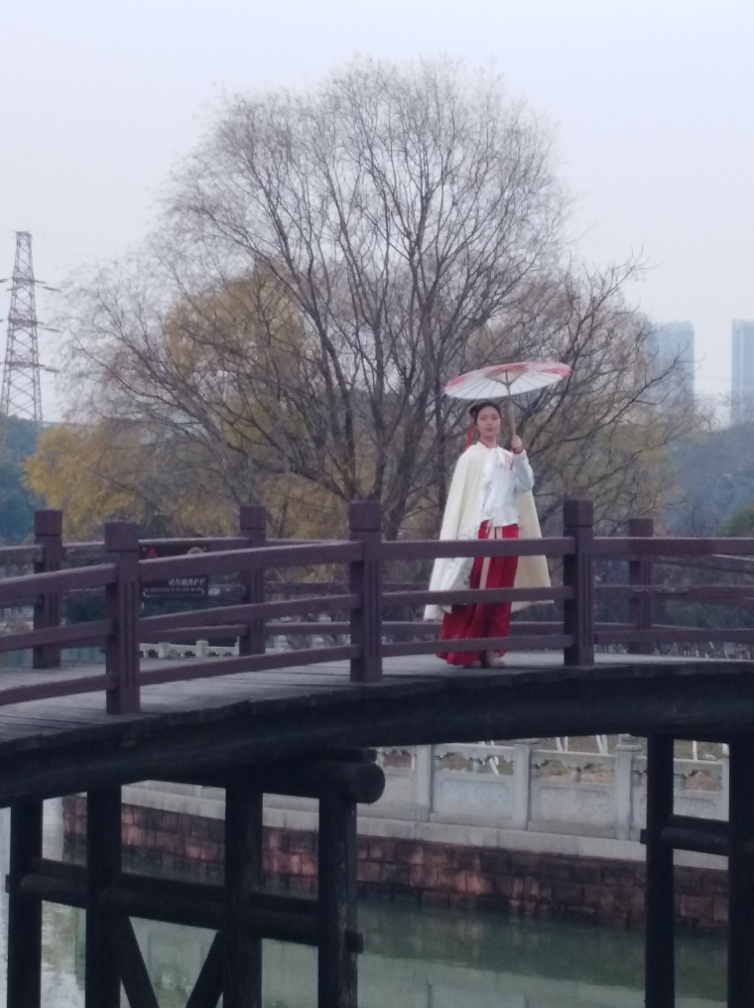What time of year does this scene likely represent, and why? The scene suggests it could be late autumn or early winter. The deciduous tree in the background has bare branches, indicating that it has shed its leaves, which commonly happens during these seasons. Moreover, the overcast sky and absence of vibrant foliage support this time frame. Is there any cultural significance to the attire that the person is wearing? The person is dressed in traditional clothing that appears to be of East Asian influence, likely drawing from historical styles seen in regions such as China, Japan, or Korea. Such attire can reflect cultural heritage and is often worn during festivals, cultural events, or historical reenactments to celebrate and preserve traditional customs. 